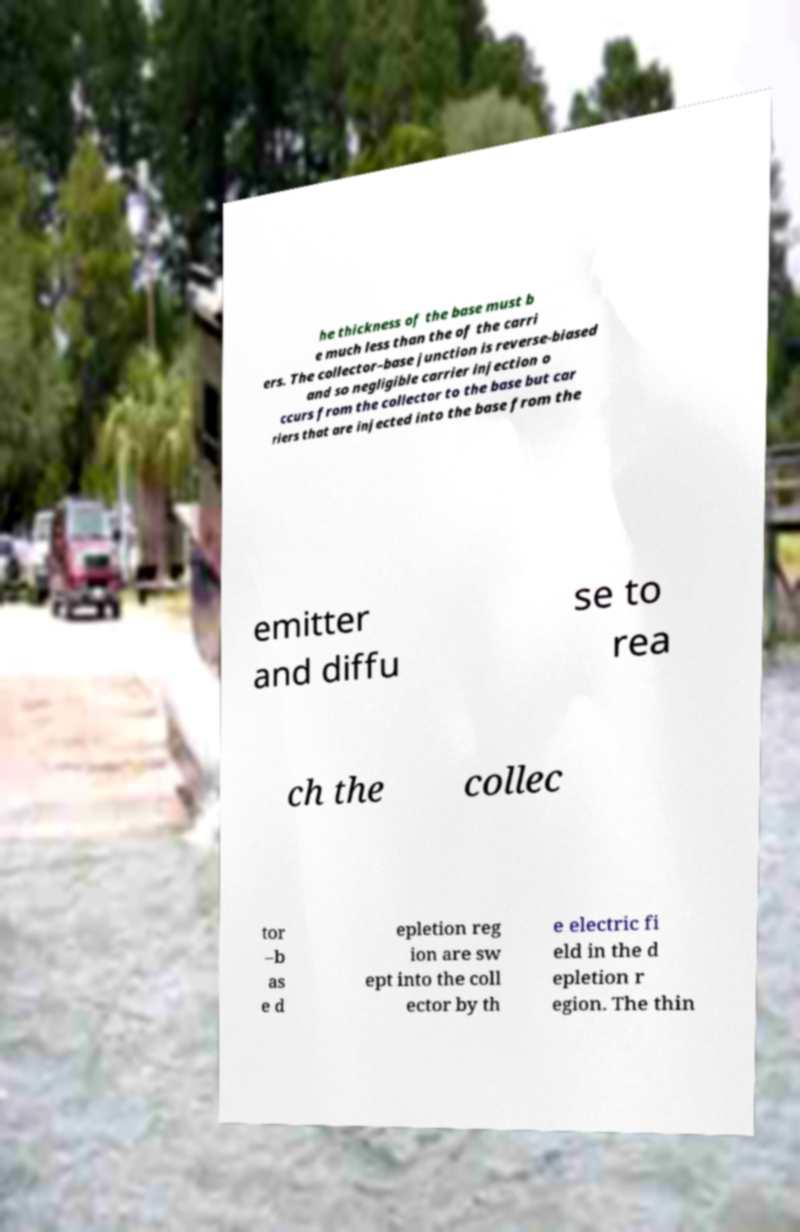I need the written content from this picture converted into text. Can you do that? he thickness of the base must b e much less than the of the carri ers. The collector–base junction is reverse-biased and so negligible carrier injection o ccurs from the collector to the base but car riers that are injected into the base from the emitter and diffu se to rea ch the collec tor –b as e d epletion reg ion are sw ept into the coll ector by th e electric fi eld in the d epletion r egion. The thin 